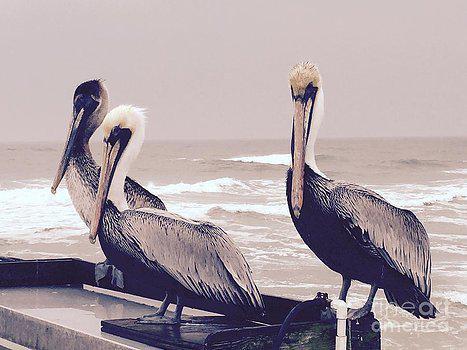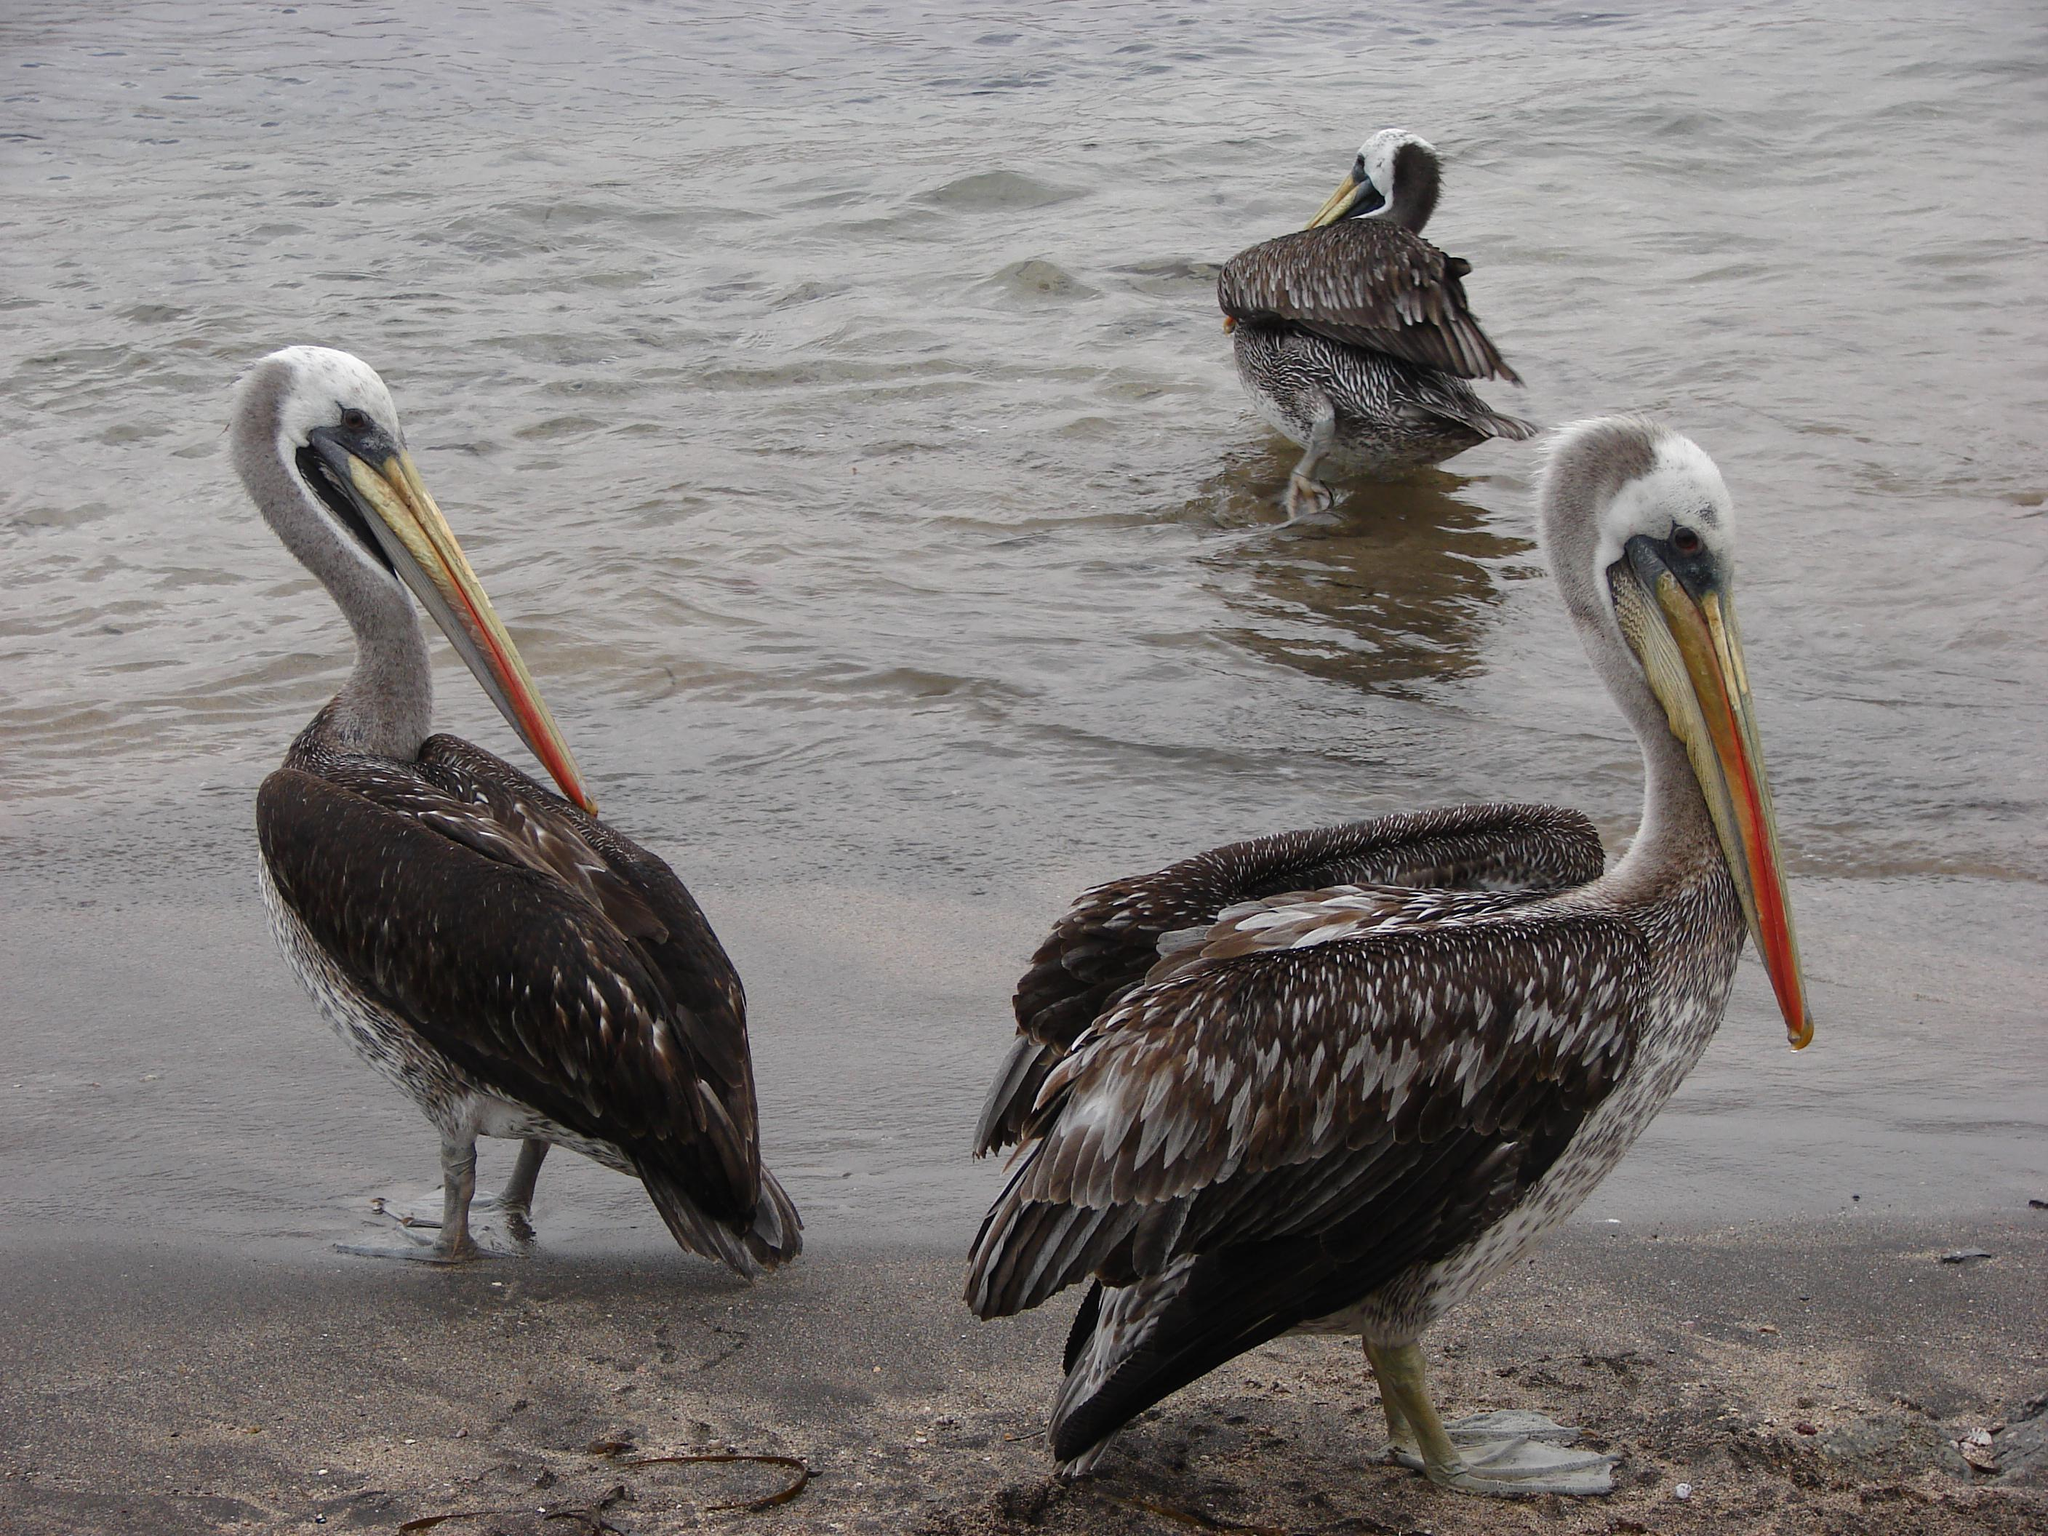The first image is the image on the left, the second image is the image on the right. Examine the images to the left and right. Is the description "Three birds in the image on the left are standing on a manmade object near the water." accurate? Answer yes or no. Yes. The first image is the image on the left, the second image is the image on the right. For the images shown, is this caption "An image shows at least two pelicans standing on a flat manmade platform over the water." true? Answer yes or no. Yes. 